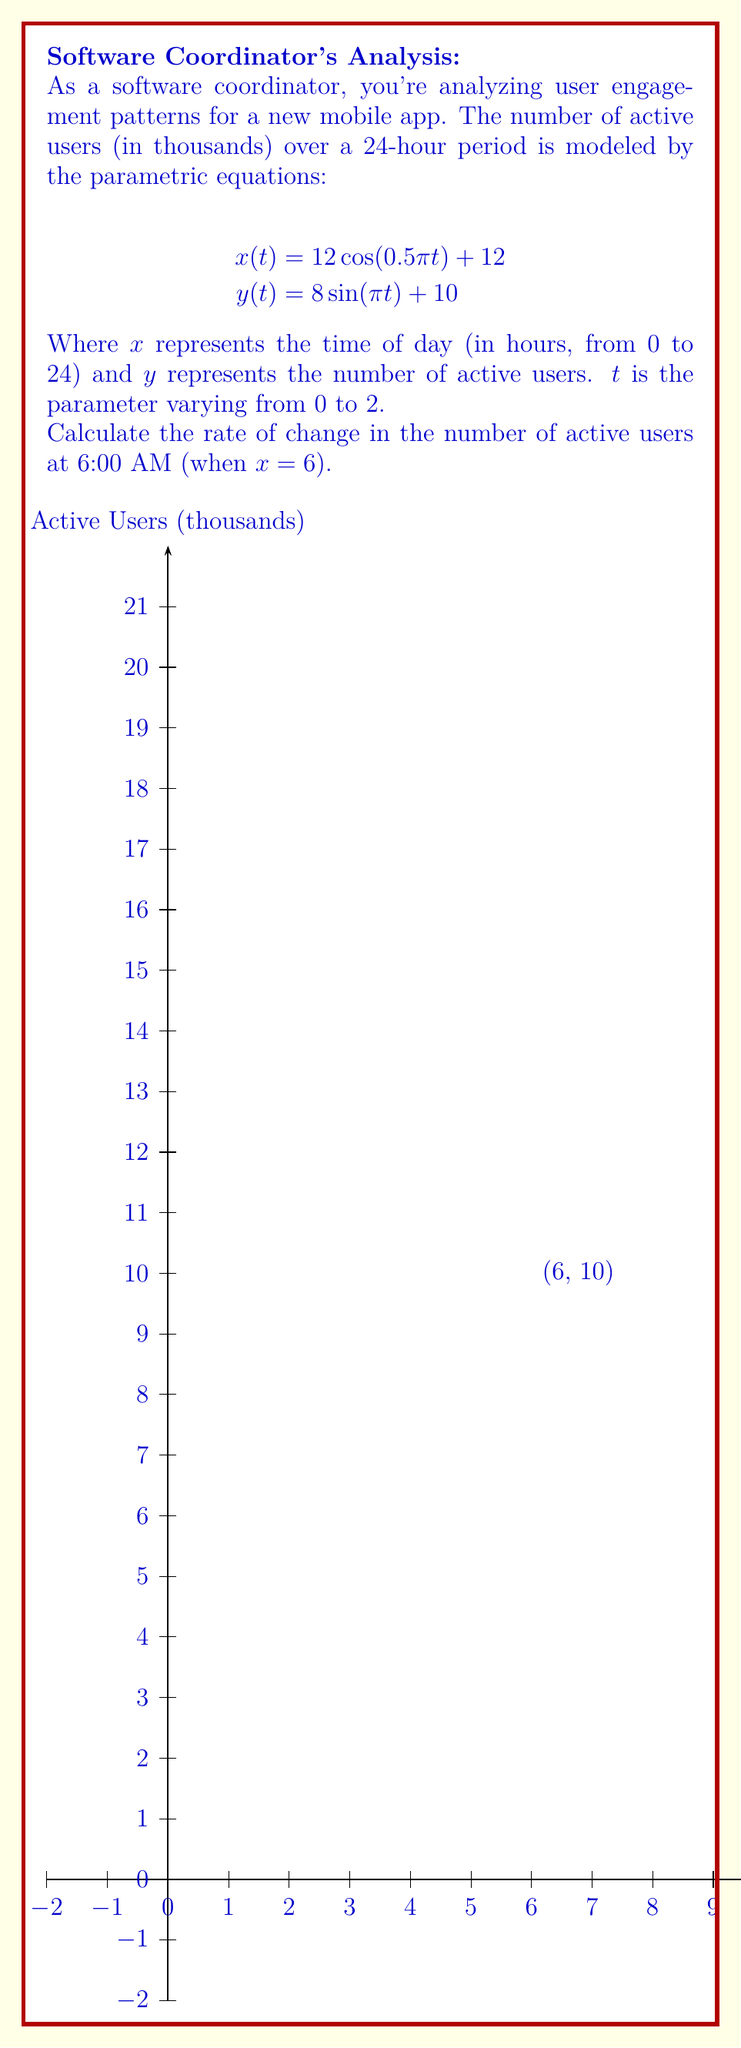Could you help me with this problem? Let's approach this step-by-step:

1) First, we need to find the value of $t$ when $x = 6$. We can use the equation for $x(t)$:

   $$6 = 12 \cos(0.5\pi t) + 12$$

2) Solving for $t$:
   $$-6 = 12 \cos(0.5\pi t)$$
   $$-0.5 = \cos(0.5\pi t)$$
   $$t = \frac{2}{\pi} \arccos(-0.5) \approx 0.7297$$

3) Now that we have $t$, we can find $\frac{dy}{dt}$ and $\frac{dx}{dt}$ at this point:

   $$\frac{dx}{dt} = -6\pi \sin(0.5\pi t)$$
   $$\frac{dy}{dt} = 8\pi \cos(\pi t)$$

4) Evaluating these at $t \approx 0.7297$:

   $$\frac{dx}{dt} \approx -5.1962$$
   $$\frac{dy}{dt} \approx -7.3304$$

5) The rate of change of $y$ with respect to $x$ is given by:

   $$\frac{dy}{dx} = \frac{dy/dt}{dx/dt}$$

6) Substituting our values:

   $$\frac{dy}{dx} \approx \frac{-7.3304}{-5.1962} \approx 1.4107$$

Therefore, at 6:00 AM, the rate of change in the number of active users is approximately 1.4107 thousand users per hour.
Answer: 1.4107 thousand users per hour 